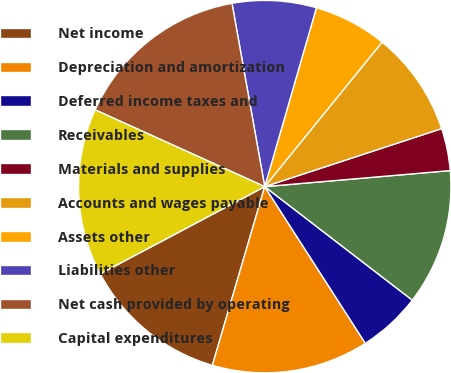Convert chart to OTSL. <chart><loc_0><loc_0><loc_500><loc_500><pie_chart><fcel>Net income<fcel>Depreciation and amortization<fcel>Deferred income taxes and<fcel>Receivables<fcel>Materials and supplies<fcel>Accounts and wages payable<fcel>Assets other<fcel>Liabilities other<fcel>Net cash provided by operating<fcel>Capital expenditures<nl><fcel>12.71%<fcel>13.62%<fcel>5.48%<fcel>11.81%<fcel>3.67%<fcel>9.1%<fcel>6.38%<fcel>7.29%<fcel>15.42%<fcel>14.52%<nl></chart> 